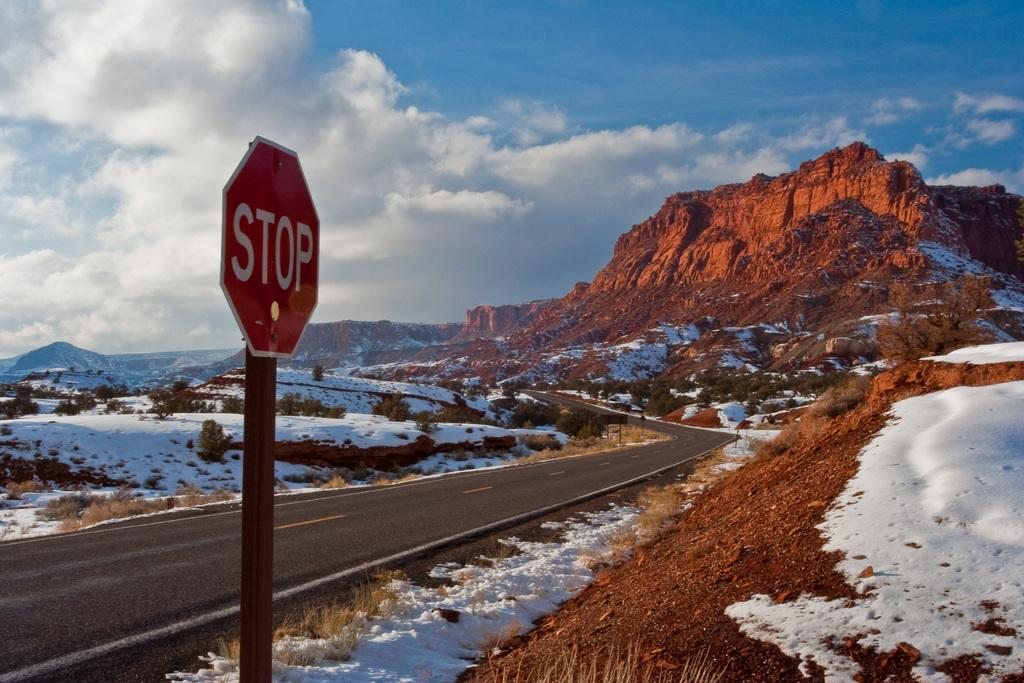<image>
Write a terse but informative summary of the picture. Large red STOP sign in front of some mountain. 